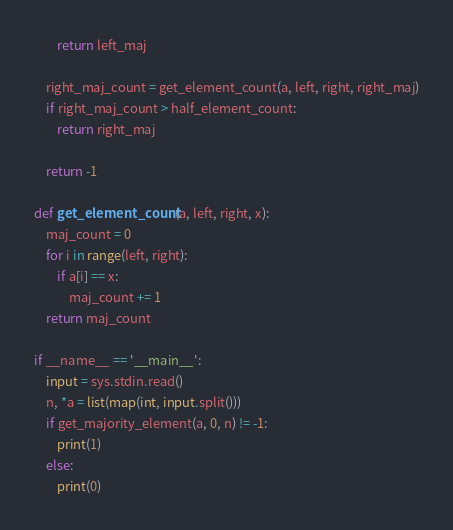<code> <loc_0><loc_0><loc_500><loc_500><_Python_>        return left_maj

    right_maj_count = get_element_count(a, left, right, right_maj)
    if right_maj_count > half_element_count:
        return right_maj

    return -1

def get_element_count(a, left, right, x):
    maj_count = 0
    for i in range(left, right):
        if a[i] == x:
            maj_count += 1
    return maj_count

if __name__ == '__main__':
    input = sys.stdin.read()
    n, *a = list(map(int, input.split()))
    if get_majority_element(a, 0, n) != -1:
        print(1)
    else:
        print(0)
</code> 